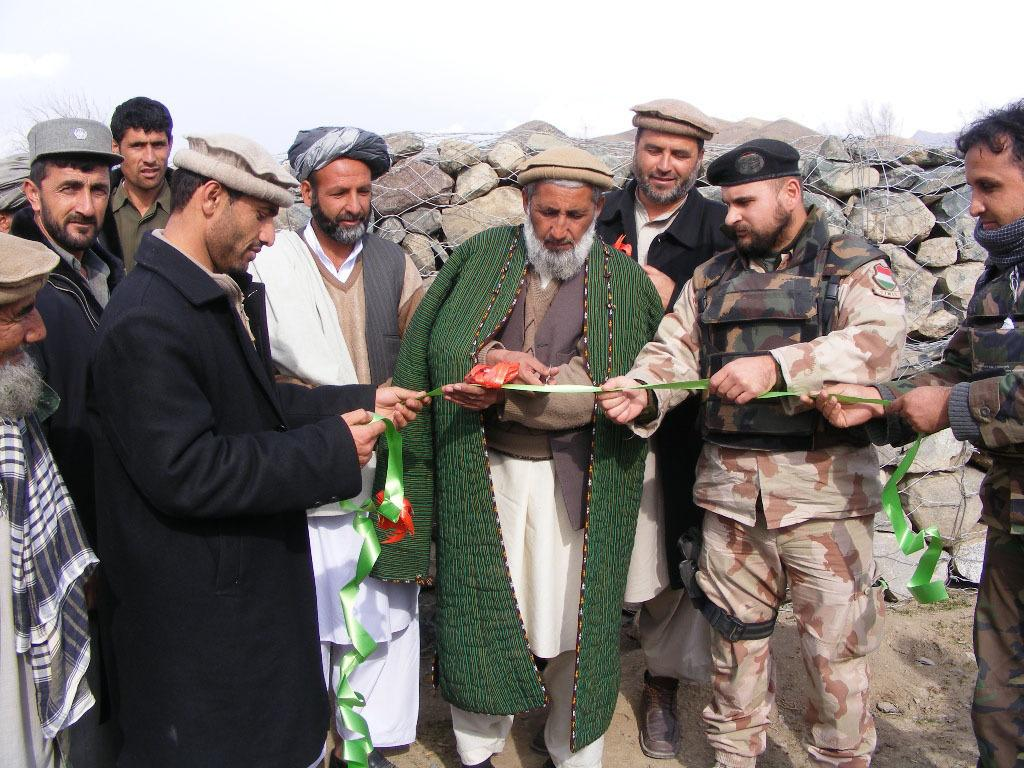How many people are in the image? There is a group of people in the image. What are some people doing in the image? Some people are holding a ribbon. What can be seen in the background of the image? There is a stone wall in the background of the image. What type of curtain is hanging from the stone wall in the image? There is no curtain present in the image; only a group of people and a stone wall are visible. What kind of fruit can be seen growing on the stone wall in the image? There is no fruit visible on the stone wall in the image. 